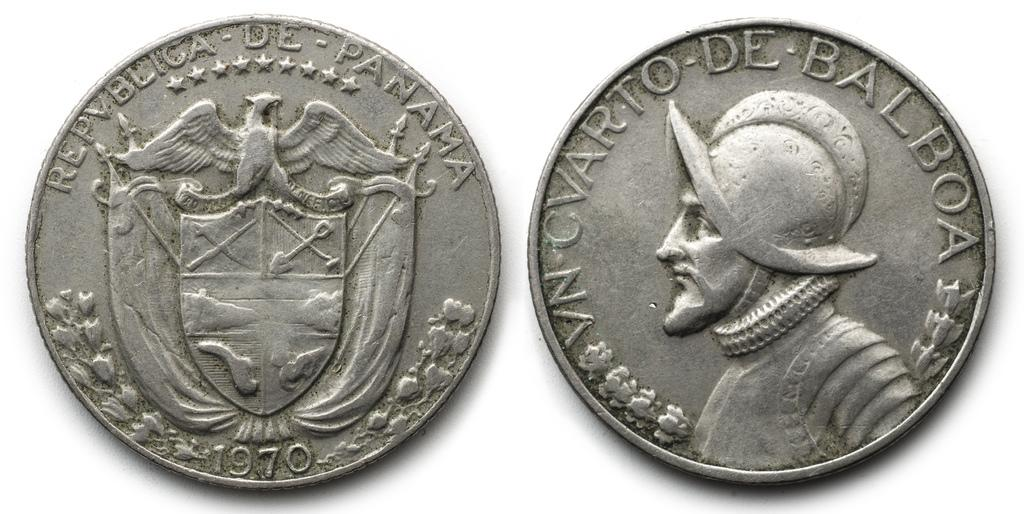Provide a one-sentence caption for the provided image. A silver colored Republic of Panama coin from 1970. 